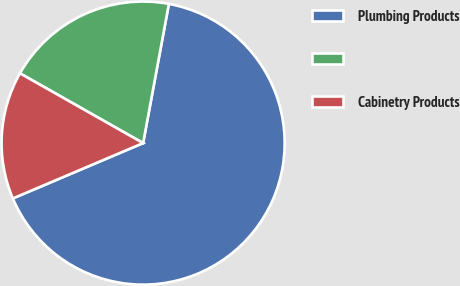Convert chart. <chart><loc_0><loc_0><loc_500><loc_500><pie_chart><fcel>Plumbing Products<fcel>Unnamed: 1<fcel>Cabinetry Products<nl><fcel>65.69%<fcel>19.71%<fcel>14.6%<nl></chart> 